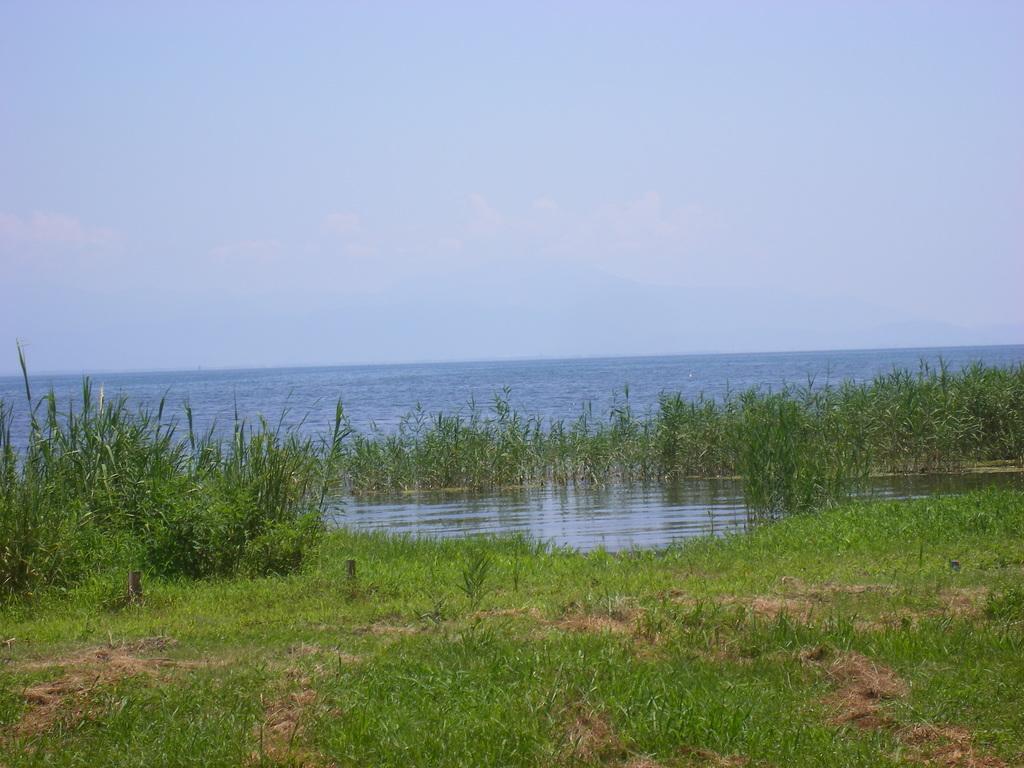In one or two sentences, can you explain what this image depicts? In this image, we can see plants, grass and water. Background there is the sky. 